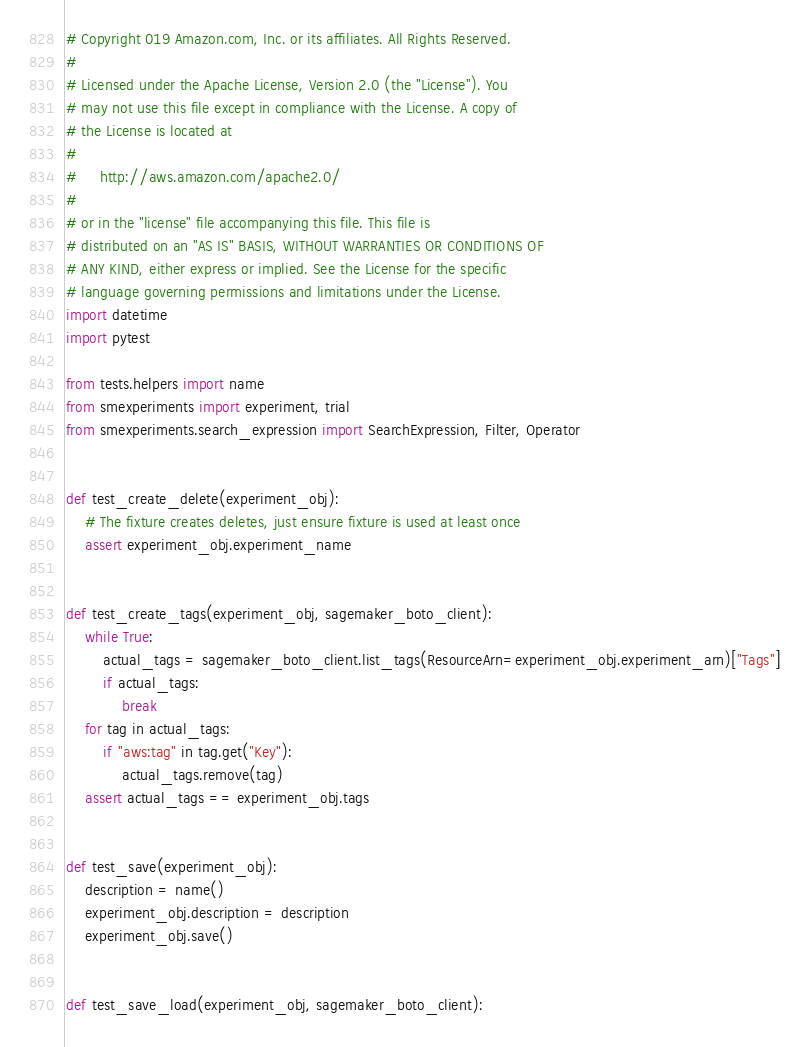Convert code to text. <code><loc_0><loc_0><loc_500><loc_500><_Python_># Copyright 019 Amazon.com, Inc. or its affiliates. All Rights Reserved.
#
# Licensed under the Apache License, Version 2.0 (the "License"). You
# may not use this file except in compliance with the License. A copy of
# the License is located at
#
#     http://aws.amazon.com/apache2.0/
#
# or in the "license" file accompanying this file. This file is
# distributed on an "AS IS" BASIS, WITHOUT WARRANTIES OR CONDITIONS OF
# ANY KIND, either express or implied. See the License for the specific
# language governing permissions and limitations under the License.
import datetime
import pytest

from tests.helpers import name
from smexperiments import experiment, trial
from smexperiments.search_expression import SearchExpression, Filter, Operator


def test_create_delete(experiment_obj):
    # The fixture creates deletes, just ensure fixture is used at least once
    assert experiment_obj.experiment_name


def test_create_tags(experiment_obj, sagemaker_boto_client):
    while True:
        actual_tags = sagemaker_boto_client.list_tags(ResourceArn=experiment_obj.experiment_arn)["Tags"]
        if actual_tags:
            break
    for tag in actual_tags:
        if "aws:tag" in tag.get("Key"):
            actual_tags.remove(tag)
    assert actual_tags == experiment_obj.tags


def test_save(experiment_obj):
    description = name()
    experiment_obj.description = description
    experiment_obj.save()


def test_save_load(experiment_obj, sagemaker_boto_client):</code> 